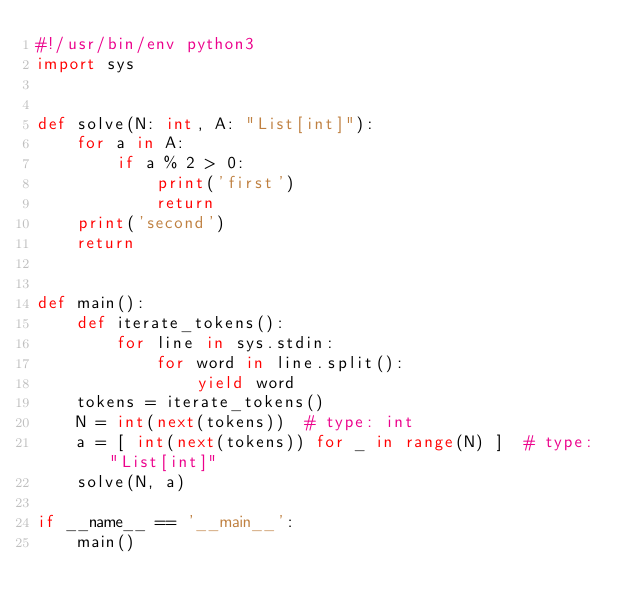Convert code to text. <code><loc_0><loc_0><loc_500><loc_500><_Python_>#!/usr/bin/env python3
import sys


def solve(N: int, A: "List[int]"):
    for a in A:
        if a % 2 > 0:
            print('first')
            return
    print('second')
    return


def main():
    def iterate_tokens():
        for line in sys.stdin:
            for word in line.split():
                yield word
    tokens = iterate_tokens()
    N = int(next(tokens))  # type: int
    a = [ int(next(tokens)) for _ in range(N) ]  # type: "List[int]"
    solve(N, a)

if __name__ == '__main__':
    main()
</code> 